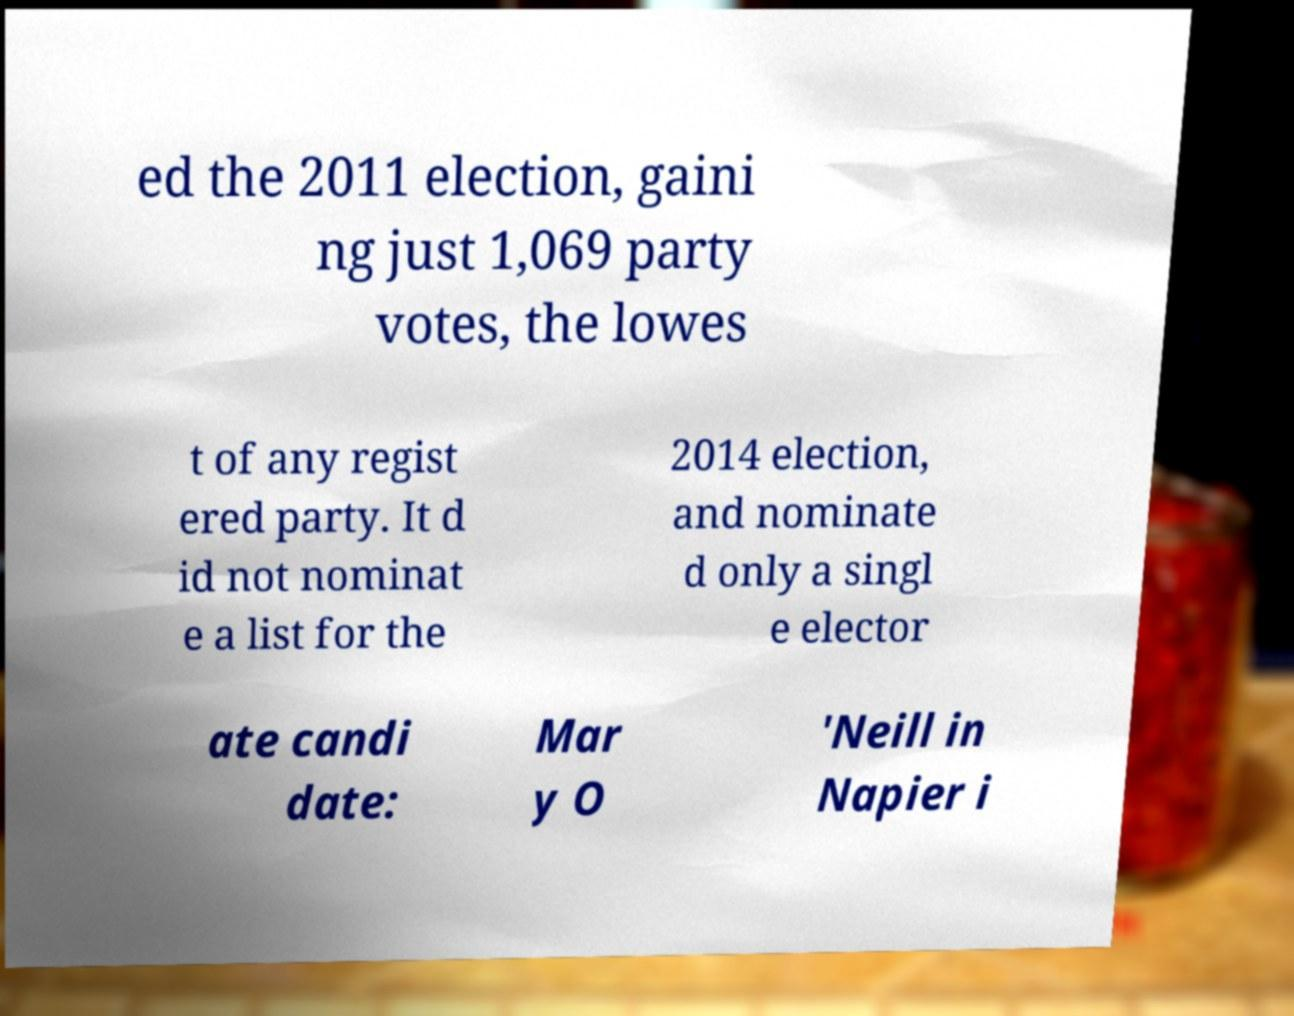Could you assist in decoding the text presented in this image and type it out clearly? ed the 2011 election, gaini ng just 1,069 party votes, the lowes t of any regist ered party. It d id not nominat e a list for the 2014 election, and nominate d only a singl e elector ate candi date: Mar y O 'Neill in Napier i 